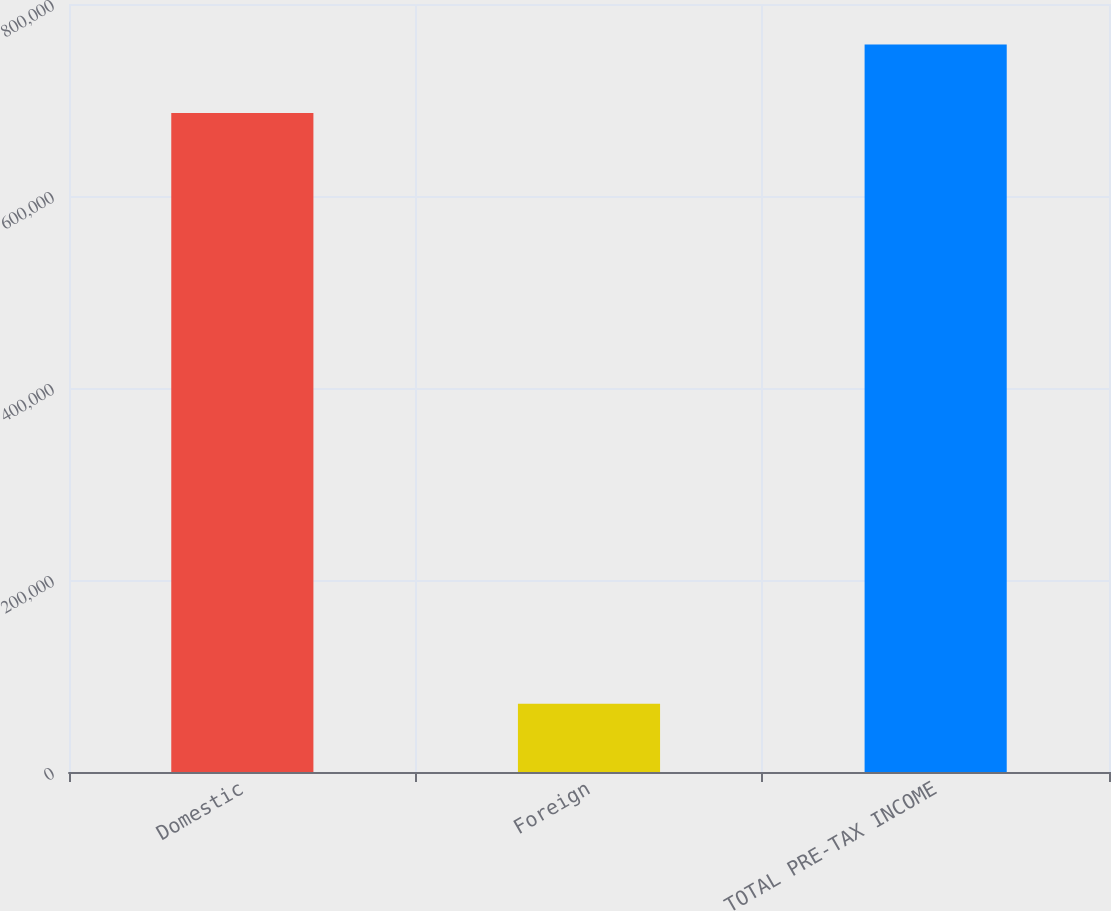Convert chart. <chart><loc_0><loc_0><loc_500><loc_500><bar_chart><fcel>Domestic<fcel>Foreign<fcel>TOTAL PRE-TAX INCOME<nl><fcel>686571<fcel>71180<fcel>757751<nl></chart> 